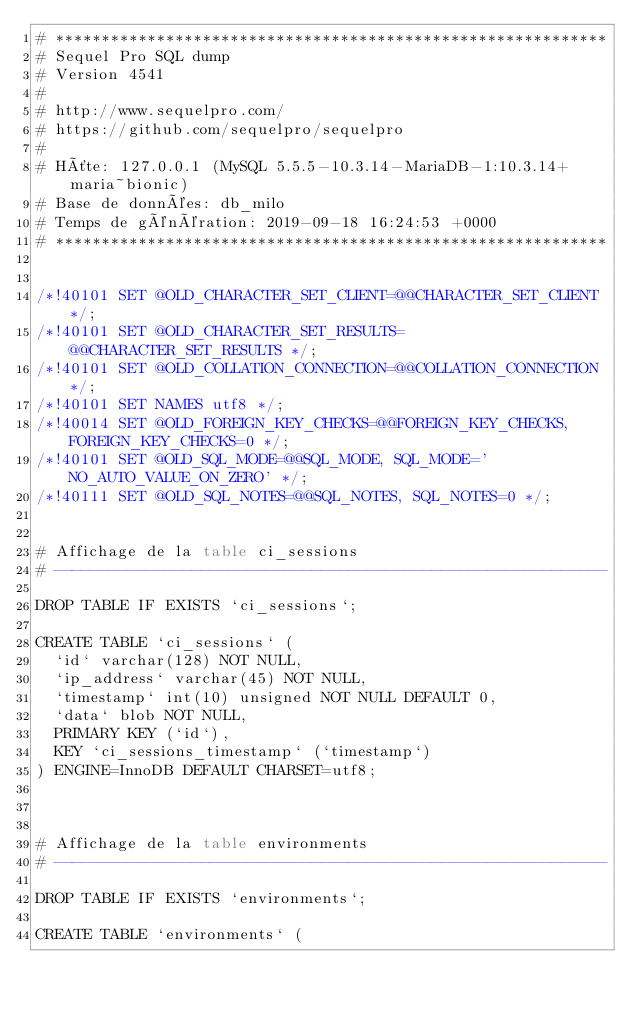Convert code to text. <code><loc_0><loc_0><loc_500><loc_500><_SQL_># ************************************************************
# Sequel Pro SQL dump
# Version 4541
#
# http://www.sequelpro.com/
# https://github.com/sequelpro/sequelpro
#
# Hôte: 127.0.0.1 (MySQL 5.5.5-10.3.14-MariaDB-1:10.3.14+maria~bionic)
# Base de données: db_milo
# Temps de génération: 2019-09-18 16:24:53 +0000
# ************************************************************


/*!40101 SET @OLD_CHARACTER_SET_CLIENT=@@CHARACTER_SET_CLIENT */;
/*!40101 SET @OLD_CHARACTER_SET_RESULTS=@@CHARACTER_SET_RESULTS */;
/*!40101 SET @OLD_COLLATION_CONNECTION=@@COLLATION_CONNECTION */;
/*!40101 SET NAMES utf8 */;
/*!40014 SET @OLD_FOREIGN_KEY_CHECKS=@@FOREIGN_KEY_CHECKS, FOREIGN_KEY_CHECKS=0 */;
/*!40101 SET @OLD_SQL_MODE=@@SQL_MODE, SQL_MODE='NO_AUTO_VALUE_ON_ZERO' */;
/*!40111 SET @OLD_SQL_NOTES=@@SQL_NOTES, SQL_NOTES=0 */;


# Affichage de la table ci_sessions
# ------------------------------------------------------------

DROP TABLE IF EXISTS `ci_sessions`;

CREATE TABLE `ci_sessions` (
  `id` varchar(128) NOT NULL,
  `ip_address` varchar(45) NOT NULL,
  `timestamp` int(10) unsigned NOT NULL DEFAULT 0,
  `data` blob NOT NULL,
  PRIMARY KEY (`id`),
  KEY `ci_sessions_timestamp` (`timestamp`)
) ENGINE=InnoDB DEFAULT CHARSET=utf8;



# Affichage de la table environments
# ------------------------------------------------------------

DROP TABLE IF EXISTS `environments`;

CREATE TABLE `environments` (</code> 